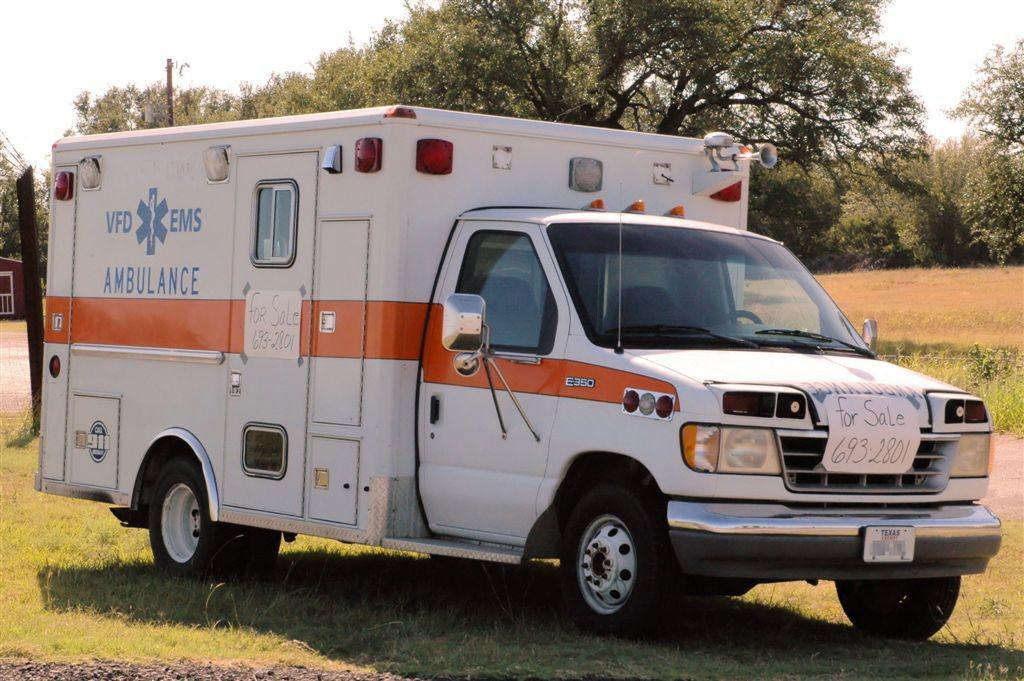<image>
Share a concise interpretation of the image provided. An ambulance says VFD and EMS on the side of it. 